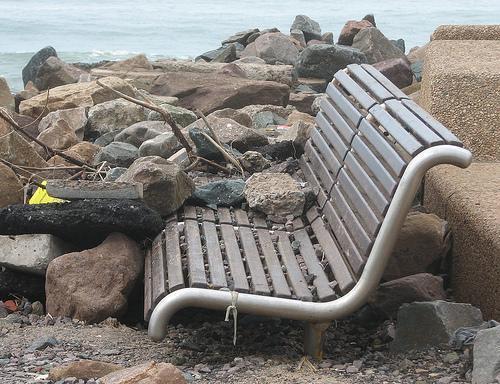How many bench are there?
Give a very brief answer. 1. 